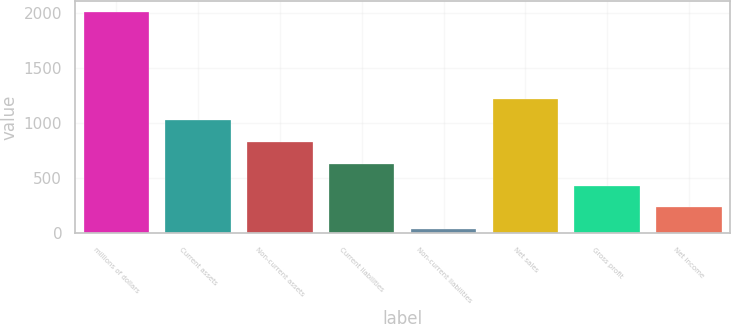Convert chart. <chart><loc_0><loc_0><loc_500><loc_500><bar_chart><fcel>millions of dollars<fcel>Current assets<fcel>Non-current assets<fcel>Current liabilities<fcel>Non-current liabilities<fcel>Net sales<fcel>Gross profit<fcel>Net income<nl><fcel>2008<fcel>1024.25<fcel>827.5<fcel>630.75<fcel>40.5<fcel>1221<fcel>434<fcel>237.25<nl></chart> 